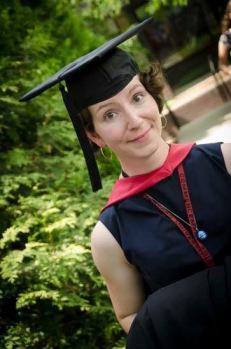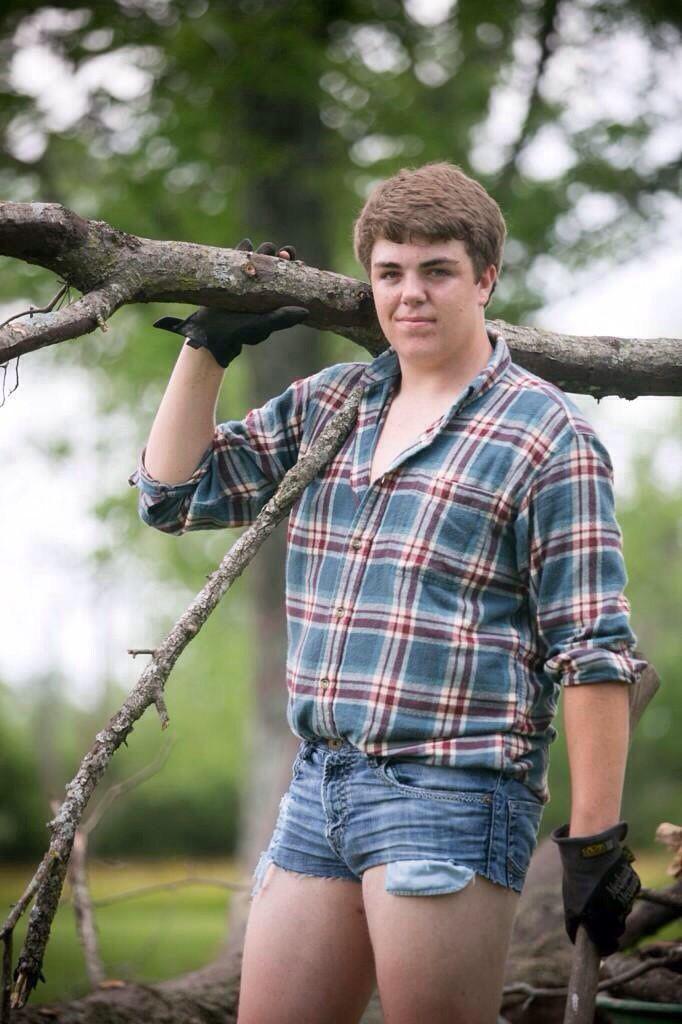The first image is the image on the left, the second image is the image on the right. Given the left and right images, does the statement "There is exactly one person in cap and gown in the right image." hold true? Answer yes or no. No. The first image is the image on the left, the second image is the image on the right. Given the left and right images, does the statement "And at least one image there is a single female with long white hair holding a rolled up white diploma while still dressed in her cap and gown." hold true? Answer yes or no. No. 